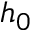<formula> <loc_0><loc_0><loc_500><loc_500>h _ { 0 }</formula> 